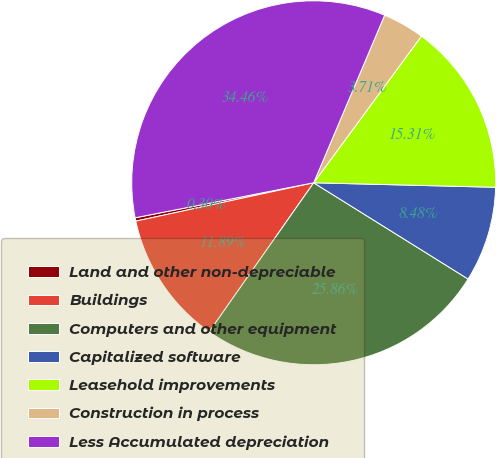<chart> <loc_0><loc_0><loc_500><loc_500><pie_chart><fcel>Land and other non-depreciable<fcel>Buildings<fcel>Computers and other equipment<fcel>Capitalized software<fcel>Leasehold improvements<fcel>Construction in process<fcel>Less Accumulated depreciation<nl><fcel>0.3%<fcel>11.89%<fcel>25.86%<fcel>8.48%<fcel>15.31%<fcel>3.71%<fcel>34.46%<nl></chart> 